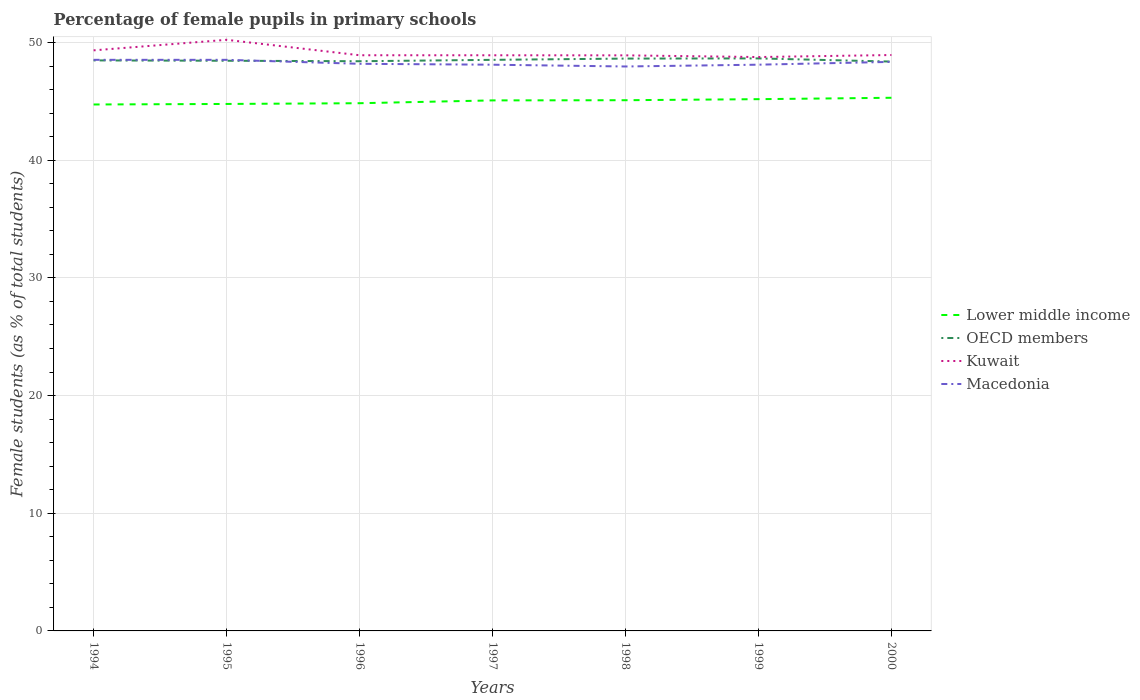Does the line corresponding to Macedonia intersect with the line corresponding to OECD members?
Provide a short and direct response. Yes. Across all years, what is the maximum percentage of female pupils in primary schools in OECD members?
Ensure brevity in your answer.  48.39. In which year was the percentage of female pupils in primary schools in Kuwait maximum?
Give a very brief answer. 1999. What is the total percentage of female pupils in primary schools in Macedonia in the graph?
Your answer should be compact. 0.34. What is the difference between the highest and the second highest percentage of female pupils in primary schools in OECD members?
Your response must be concise. 0.27. What is the difference between the highest and the lowest percentage of female pupils in primary schools in OECD members?
Provide a short and direct response. 3. Is the percentage of female pupils in primary schools in Kuwait strictly greater than the percentage of female pupils in primary schools in Lower middle income over the years?
Your answer should be very brief. No. How many lines are there?
Offer a terse response. 4. What is the difference between two consecutive major ticks on the Y-axis?
Provide a succinct answer. 10. Does the graph contain any zero values?
Provide a succinct answer. No. What is the title of the graph?
Keep it short and to the point. Percentage of female pupils in primary schools. What is the label or title of the Y-axis?
Offer a very short reply. Female students (as % of total students). What is the Female students (as % of total students) of Lower middle income in 1994?
Ensure brevity in your answer.  44.74. What is the Female students (as % of total students) in OECD members in 1994?
Offer a very short reply. 48.49. What is the Female students (as % of total students) of Kuwait in 1994?
Give a very brief answer. 49.34. What is the Female students (as % of total students) in Macedonia in 1994?
Keep it short and to the point. 48.54. What is the Female students (as % of total students) in Lower middle income in 1995?
Provide a succinct answer. 44.79. What is the Female students (as % of total students) in OECD members in 1995?
Offer a terse response. 48.46. What is the Female students (as % of total students) in Kuwait in 1995?
Your response must be concise. 50.24. What is the Female students (as % of total students) in Macedonia in 1995?
Make the answer very short. 48.54. What is the Female students (as % of total students) of Lower middle income in 1996?
Make the answer very short. 44.85. What is the Female students (as % of total students) of OECD members in 1996?
Your response must be concise. 48.42. What is the Female students (as % of total students) of Kuwait in 1996?
Offer a terse response. 48.93. What is the Female students (as % of total students) in Macedonia in 1996?
Your response must be concise. 48.2. What is the Female students (as % of total students) in Lower middle income in 1997?
Offer a terse response. 45.09. What is the Female students (as % of total students) of OECD members in 1997?
Provide a succinct answer. 48.54. What is the Female students (as % of total students) in Kuwait in 1997?
Your response must be concise. 48.92. What is the Female students (as % of total students) of Macedonia in 1997?
Your response must be concise. 48.12. What is the Female students (as % of total students) in Lower middle income in 1998?
Your response must be concise. 45.1. What is the Female students (as % of total students) in OECD members in 1998?
Your response must be concise. 48.64. What is the Female students (as % of total students) of Kuwait in 1998?
Keep it short and to the point. 48.92. What is the Female students (as % of total students) of Macedonia in 1998?
Provide a short and direct response. 47.97. What is the Female students (as % of total students) in Lower middle income in 1999?
Offer a very short reply. 45.19. What is the Female students (as % of total students) in OECD members in 1999?
Ensure brevity in your answer.  48.66. What is the Female students (as % of total students) of Kuwait in 1999?
Offer a terse response. 48.77. What is the Female students (as % of total students) in Macedonia in 1999?
Provide a short and direct response. 48.12. What is the Female students (as % of total students) in Lower middle income in 2000?
Keep it short and to the point. 45.31. What is the Female students (as % of total students) of OECD members in 2000?
Provide a succinct answer. 48.39. What is the Female students (as % of total students) of Kuwait in 2000?
Your response must be concise. 48.94. What is the Female students (as % of total students) of Macedonia in 2000?
Offer a very short reply. 48.36. Across all years, what is the maximum Female students (as % of total students) of Lower middle income?
Keep it short and to the point. 45.31. Across all years, what is the maximum Female students (as % of total students) of OECD members?
Ensure brevity in your answer.  48.66. Across all years, what is the maximum Female students (as % of total students) of Kuwait?
Your answer should be very brief. 50.24. Across all years, what is the maximum Female students (as % of total students) in Macedonia?
Offer a very short reply. 48.54. Across all years, what is the minimum Female students (as % of total students) in Lower middle income?
Ensure brevity in your answer.  44.74. Across all years, what is the minimum Female students (as % of total students) of OECD members?
Provide a short and direct response. 48.39. Across all years, what is the minimum Female students (as % of total students) in Kuwait?
Your answer should be very brief. 48.77. Across all years, what is the minimum Female students (as % of total students) in Macedonia?
Keep it short and to the point. 47.97. What is the total Female students (as % of total students) of Lower middle income in the graph?
Offer a terse response. 315.07. What is the total Female students (as % of total students) in OECD members in the graph?
Your answer should be compact. 339.58. What is the total Female students (as % of total students) in Kuwait in the graph?
Offer a terse response. 344.06. What is the total Female students (as % of total students) in Macedonia in the graph?
Provide a succinct answer. 337.85. What is the difference between the Female students (as % of total students) of Lower middle income in 1994 and that in 1995?
Give a very brief answer. -0.05. What is the difference between the Female students (as % of total students) in OECD members in 1994 and that in 1995?
Offer a very short reply. 0.03. What is the difference between the Female students (as % of total students) of Kuwait in 1994 and that in 1995?
Ensure brevity in your answer.  -0.9. What is the difference between the Female students (as % of total students) of Macedonia in 1994 and that in 1995?
Keep it short and to the point. 0. What is the difference between the Female students (as % of total students) in Lower middle income in 1994 and that in 1996?
Offer a terse response. -0.11. What is the difference between the Female students (as % of total students) in OECD members in 1994 and that in 1996?
Ensure brevity in your answer.  0.07. What is the difference between the Female students (as % of total students) in Kuwait in 1994 and that in 1996?
Keep it short and to the point. 0.42. What is the difference between the Female students (as % of total students) in Macedonia in 1994 and that in 1996?
Provide a succinct answer. 0.34. What is the difference between the Female students (as % of total students) of Lower middle income in 1994 and that in 1997?
Your answer should be compact. -0.35. What is the difference between the Female students (as % of total students) in OECD members in 1994 and that in 1997?
Provide a short and direct response. -0.05. What is the difference between the Female students (as % of total students) in Kuwait in 1994 and that in 1997?
Make the answer very short. 0.42. What is the difference between the Female students (as % of total students) in Macedonia in 1994 and that in 1997?
Your response must be concise. 0.42. What is the difference between the Female students (as % of total students) in Lower middle income in 1994 and that in 1998?
Your answer should be compact. -0.36. What is the difference between the Female students (as % of total students) in OECD members in 1994 and that in 1998?
Your answer should be very brief. -0.16. What is the difference between the Female students (as % of total students) of Kuwait in 1994 and that in 1998?
Offer a terse response. 0.43. What is the difference between the Female students (as % of total students) in Macedonia in 1994 and that in 1998?
Offer a terse response. 0.57. What is the difference between the Female students (as % of total students) of Lower middle income in 1994 and that in 1999?
Ensure brevity in your answer.  -0.45. What is the difference between the Female students (as % of total students) in OECD members in 1994 and that in 1999?
Provide a short and direct response. -0.17. What is the difference between the Female students (as % of total students) of Kuwait in 1994 and that in 1999?
Offer a terse response. 0.57. What is the difference between the Female students (as % of total students) in Macedonia in 1994 and that in 1999?
Your response must be concise. 0.41. What is the difference between the Female students (as % of total students) of Lower middle income in 1994 and that in 2000?
Offer a terse response. -0.57. What is the difference between the Female students (as % of total students) of OECD members in 1994 and that in 2000?
Give a very brief answer. 0.1. What is the difference between the Female students (as % of total students) in Kuwait in 1994 and that in 2000?
Keep it short and to the point. 0.4. What is the difference between the Female students (as % of total students) in Macedonia in 1994 and that in 2000?
Offer a very short reply. 0.17. What is the difference between the Female students (as % of total students) in Lower middle income in 1995 and that in 1996?
Keep it short and to the point. -0.06. What is the difference between the Female students (as % of total students) in OECD members in 1995 and that in 1996?
Provide a short and direct response. 0.04. What is the difference between the Female students (as % of total students) in Kuwait in 1995 and that in 1996?
Your answer should be very brief. 1.31. What is the difference between the Female students (as % of total students) in Macedonia in 1995 and that in 1996?
Ensure brevity in your answer.  0.34. What is the difference between the Female students (as % of total students) of Lower middle income in 1995 and that in 1997?
Ensure brevity in your answer.  -0.3. What is the difference between the Female students (as % of total students) of OECD members in 1995 and that in 1997?
Make the answer very short. -0.08. What is the difference between the Female students (as % of total students) in Kuwait in 1995 and that in 1997?
Your response must be concise. 1.31. What is the difference between the Female students (as % of total students) in Macedonia in 1995 and that in 1997?
Your answer should be very brief. 0.42. What is the difference between the Female students (as % of total students) of Lower middle income in 1995 and that in 1998?
Keep it short and to the point. -0.32. What is the difference between the Female students (as % of total students) of OECD members in 1995 and that in 1998?
Provide a short and direct response. -0.19. What is the difference between the Female students (as % of total students) of Kuwait in 1995 and that in 1998?
Give a very brief answer. 1.32. What is the difference between the Female students (as % of total students) in Macedonia in 1995 and that in 1998?
Your answer should be very brief. 0.57. What is the difference between the Female students (as % of total students) of Lower middle income in 1995 and that in 1999?
Keep it short and to the point. -0.41. What is the difference between the Female students (as % of total students) of OECD members in 1995 and that in 1999?
Make the answer very short. -0.2. What is the difference between the Female students (as % of total students) of Kuwait in 1995 and that in 1999?
Make the answer very short. 1.47. What is the difference between the Female students (as % of total students) in Macedonia in 1995 and that in 1999?
Offer a very short reply. 0.41. What is the difference between the Female students (as % of total students) of Lower middle income in 1995 and that in 2000?
Your answer should be compact. -0.53. What is the difference between the Female students (as % of total students) in OECD members in 1995 and that in 2000?
Your response must be concise. 0.07. What is the difference between the Female students (as % of total students) of Kuwait in 1995 and that in 2000?
Give a very brief answer. 1.29. What is the difference between the Female students (as % of total students) in Macedonia in 1995 and that in 2000?
Make the answer very short. 0.17. What is the difference between the Female students (as % of total students) of Lower middle income in 1996 and that in 1997?
Give a very brief answer. -0.24. What is the difference between the Female students (as % of total students) of OECD members in 1996 and that in 1997?
Make the answer very short. -0.12. What is the difference between the Female students (as % of total students) in Kuwait in 1996 and that in 1997?
Your answer should be compact. 0. What is the difference between the Female students (as % of total students) of Macedonia in 1996 and that in 1997?
Make the answer very short. 0.08. What is the difference between the Female students (as % of total students) in Lower middle income in 1996 and that in 1998?
Make the answer very short. -0.26. What is the difference between the Female students (as % of total students) in OECD members in 1996 and that in 1998?
Your answer should be very brief. -0.23. What is the difference between the Female students (as % of total students) of Kuwait in 1996 and that in 1998?
Your response must be concise. 0.01. What is the difference between the Female students (as % of total students) in Macedonia in 1996 and that in 1998?
Your answer should be compact. 0.23. What is the difference between the Female students (as % of total students) in Lower middle income in 1996 and that in 1999?
Your response must be concise. -0.34. What is the difference between the Female students (as % of total students) of OECD members in 1996 and that in 1999?
Your answer should be very brief. -0.24. What is the difference between the Female students (as % of total students) in Kuwait in 1996 and that in 1999?
Give a very brief answer. 0.15. What is the difference between the Female students (as % of total students) in Macedonia in 1996 and that in 1999?
Ensure brevity in your answer.  0.07. What is the difference between the Female students (as % of total students) of Lower middle income in 1996 and that in 2000?
Provide a short and direct response. -0.46. What is the difference between the Female students (as % of total students) in OECD members in 1996 and that in 2000?
Your answer should be very brief. 0.03. What is the difference between the Female students (as % of total students) in Kuwait in 1996 and that in 2000?
Your answer should be very brief. -0.02. What is the difference between the Female students (as % of total students) of Macedonia in 1996 and that in 2000?
Provide a succinct answer. -0.16. What is the difference between the Female students (as % of total students) of Lower middle income in 1997 and that in 1998?
Make the answer very short. -0.02. What is the difference between the Female students (as % of total students) of OECD members in 1997 and that in 1998?
Your response must be concise. -0.11. What is the difference between the Female students (as % of total students) of Kuwait in 1997 and that in 1998?
Provide a short and direct response. 0.01. What is the difference between the Female students (as % of total students) of Macedonia in 1997 and that in 1998?
Offer a very short reply. 0.15. What is the difference between the Female students (as % of total students) in Lower middle income in 1997 and that in 1999?
Offer a terse response. -0.1. What is the difference between the Female students (as % of total students) in OECD members in 1997 and that in 1999?
Give a very brief answer. -0.12. What is the difference between the Female students (as % of total students) of Kuwait in 1997 and that in 1999?
Your answer should be compact. 0.15. What is the difference between the Female students (as % of total students) in Macedonia in 1997 and that in 1999?
Keep it short and to the point. -0. What is the difference between the Female students (as % of total students) of Lower middle income in 1997 and that in 2000?
Provide a short and direct response. -0.22. What is the difference between the Female students (as % of total students) in OECD members in 1997 and that in 2000?
Provide a short and direct response. 0.15. What is the difference between the Female students (as % of total students) of Kuwait in 1997 and that in 2000?
Keep it short and to the point. -0.02. What is the difference between the Female students (as % of total students) of Macedonia in 1997 and that in 2000?
Your answer should be compact. -0.24. What is the difference between the Female students (as % of total students) of Lower middle income in 1998 and that in 1999?
Provide a short and direct response. -0.09. What is the difference between the Female students (as % of total students) of OECD members in 1998 and that in 1999?
Your answer should be compact. -0.01. What is the difference between the Female students (as % of total students) of Kuwait in 1998 and that in 1999?
Your response must be concise. 0.14. What is the difference between the Female students (as % of total students) of Macedonia in 1998 and that in 1999?
Offer a very short reply. -0.15. What is the difference between the Female students (as % of total students) of Lower middle income in 1998 and that in 2000?
Offer a very short reply. -0.21. What is the difference between the Female students (as % of total students) of OECD members in 1998 and that in 2000?
Ensure brevity in your answer.  0.26. What is the difference between the Female students (as % of total students) in Kuwait in 1998 and that in 2000?
Make the answer very short. -0.03. What is the difference between the Female students (as % of total students) in Macedonia in 1998 and that in 2000?
Make the answer very short. -0.39. What is the difference between the Female students (as % of total students) in Lower middle income in 1999 and that in 2000?
Keep it short and to the point. -0.12. What is the difference between the Female students (as % of total students) of OECD members in 1999 and that in 2000?
Ensure brevity in your answer.  0.27. What is the difference between the Female students (as % of total students) of Kuwait in 1999 and that in 2000?
Your answer should be compact. -0.17. What is the difference between the Female students (as % of total students) in Macedonia in 1999 and that in 2000?
Provide a succinct answer. -0.24. What is the difference between the Female students (as % of total students) of Lower middle income in 1994 and the Female students (as % of total students) of OECD members in 1995?
Provide a succinct answer. -3.72. What is the difference between the Female students (as % of total students) in Lower middle income in 1994 and the Female students (as % of total students) in Kuwait in 1995?
Your answer should be compact. -5.5. What is the difference between the Female students (as % of total students) in Lower middle income in 1994 and the Female students (as % of total students) in Macedonia in 1995?
Provide a succinct answer. -3.8. What is the difference between the Female students (as % of total students) of OECD members in 1994 and the Female students (as % of total students) of Kuwait in 1995?
Give a very brief answer. -1.75. What is the difference between the Female students (as % of total students) of Kuwait in 1994 and the Female students (as % of total students) of Macedonia in 1995?
Ensure brevity in your answer.  0.81. What is the difference between the Female students (as % of total students) in Lower middle income in 1994 and the Female students (as % of total students) in OECD members in 1996?
Offer a very short reply. -3.68. What is the difference between the Female students (as % of total students) of Lower middle income in 1994 and the Female students (as % of total students) of Kuwait in 1996?
Your answer should be compact. -4.18. What is the difference between the Female students (as % of total students) of Lower middle income in 1994 and the Female students (as % of total students) of Macedonia in 1996?
Make the answer very short. -3.46. What is the difference between the Female students (as % of total students) of OECD members in 1994 and the Female students (as % of total students) of Kuwait in 1996?
Your answer should be very brief. -0.44. What is the difference between the Female students (as % of total students) of OECD members in 1994 and the Female students (as % of total students) of Macedonia in 1996?
Make the answer very short. 0.29. What is the difference between the Female students (as % of total students) in Kuwait in 1994 and the Female students (as % of total students) in Macedonia in 1996?
Your response must be concise. 1.14. What is the difference between the Female students (as % of total students) in Lower middle income in 1994 and the Female students (as % of total students) in OECD members in 1997?
Make the answer very short. -3.79. What is the difference between the Female students (as % of total students) in Lower middle income in 1994 and the Female students (as % of total students) in Kuwait in 1997?
Your response must be concise. -4.18. What is the difference between the Female students (as % of total students) in Lower middle income in 1994 and the Female students (as % of total students) in Macedonia in 1997?
Your answer should be very brief. -3.38. What is the difference between the Female students (as % of total students) in OECD members in 1994 and the Female students (as % of total students) in Kuwait in 1997?
Your response must be concise. -0.44. What is the difference between the Female students (as % of total students) in OECD members in 1994 and the Female students (as % of total students) in Macedonia in 1997?
Your answer should be very brief. 0.37. What is the difference between the Female students (as % of total students) of Kuwait in 1994 and the Female students (as % of total students) of Macedonia in 1997?
Your response must be concise. 1.22. What is the difference between the Female students (as % of total students) in Lower middle income in 1994 and the Female students (as % of total students) in OECD members in 1998?
Keep it short and to the point. -3.9. What is the difference between the Female students (as % of total students) of Lower middle income in 1994 and the Female students (as % of total students) of Kuwait in 1998?
Provide a short and direct response. -4.18. What is the difference between the Female students (as % of total students) of Lower middle income in 1994 and the Female students (as % of total students) of Macedonia in 1998?
Provide a short and direct response. -3.23. What is the difference between the Female students (as % of total students) of OECD members in 1994 and the Female students (as % of total students) of Kuwait in 1998?
Ensure brevity in your answer.  -0.43. What is the difference between the Female students (as % of total students) of OECD members in 1994 and the Female students (as % of total students) of Macedonia in 1998?
Your response must be concise. 0.52. What is the difference between the Female students (as % of total students) of Kuwait in 1994 and the Female students (as % of total students) of Macedonia in 1998?
Offer a very short reply. 1.37. What is the difference between the Female students (as % of total students) of Lower middle income in 1994 and the Female students (as % of total students) of OECD members in 1999?
Offer a very short reply. -3.92. What is the difference between the Female students (as % of total students) in Lower middle income in 1994 and the Female students (as % of total students) in Kuwait in 1999?
Your answer should be compact. -4.03. What is the difference between the Female students (as % of total students) of Lower middle income in 1994 and the Female students (as % of total students) of Macedonia in 1999?
Your answer should be very brief. -3.38. What is the difference between the Female students (as % of total students) of OECD members in 1994 and the Female students (as % of total students) of Kuwait in 1999?
Your answer should be very brief. -0.29. What is the difference between the Female students (as % of total students) of OECD members in 1994 and the Female students (as % of total students) of Macedonia in 1999?
Offer a very short reply. 0.36. What is the difference between the Female students (as % of total students) of Kuwait in 1994 and the Female students (as % of total students) of Macedonia in 1999?
Give a very brief answer. 1.22. What is the difference between the Female students (as % of total students) of Lower middle income in 1994 and the Female students (as % of total students) of OECD members in 2000?
Ensure brevity in your answer.  -3.65. What is the difference between the Female students (as % of total students) of Lower middle income in 1994 and the Female students (as % of total students) of Kuwait in 2000?
Your answer should be compact. -4.2. What is the difference between the Female students (as % of total students) of Lower middle income in 1994 and the Female students (as % of total students) of Macedonia in 2000?
Give a very brief answer. -3.62. What is the difference between the Female students (as % of total students) in OECD members in 1994 and the Female students (as % of total students) in Kuwait in 2000?
Give a very brief answer. -0.46. What is the difference between the Female students (as % of total students) in OECD members in 1994 and the Female students (as % of total students) in Macedonia in 2000?
Offer a terse response. 0.12. What is the difference between the Female students (as % of total students) in Kuwait in 1994 and the Female students (as % of total students) in Macedonia in 2000?
Provide a succinct answer. 0.98. What is the difference between the Female students (as % of total students) of Lower middle income in 1995 and the Female students (as % of total students) of OECD members in 1996?
Give a very brief answer. -3.63. What is the difference between the Female students (as % of total students) of Lower middle income in 1995 and the Female students (as % of total students) of Kuwait in 1996?
Offer a terse response. -4.14. What is the difference between the Female students (as % of total students) of Lower middle income in 1995 and the Female students (as % of total students) of Macedonia in 1996?
Your response must be concise. -3.41. What is the difference between the Female students (as % of total students) in OECD members in 1995 and the Female students (as % of total students) in Kuwait in 1996?
Provide a succinct answer. -0.47. What is the difference between the Female students (as % of total students) of OECD members in 1995 and the Female students (as % of total students) of Macedonia in 1996?
Offer a terse response. 0.26. What is the difference between the Female students (as % of total students) in Kuwait in 1995 and the Female students (as % of total students) in Macedonia in 1996?
Provide a succinct answer. 2.04. What is the difference between the Female students (as % of total students) in Lower middle income in 1995 and the Female students (as % of total students) in OECD members in 1997?
Your answer should be very brief. -3.75. What is the difference between the Female students (as % of total students) of Lower middle income in 1995 and the Female students (as % of total students) of Kuwait in 1997?
Make the answer very short. -4.14. What is the difference between the Female students (as % of total students) in Lower middle income in 1995 and the Female students (as % of total students) in Macedonia in 1997?
Your answer should be compact. -3.34. What is the difference between the Female students (as % of total students) in OECD members in 1995 and the Female students (as % of total students) in Kuwait in 1997?
Give a very brief answer. -0.47. What is the difference between the Female students (as % of total students) in OECD members in 1995 and the Female students (as % of total students) in Macedonia in 1997?
Your response must be concise. 0.34. What is the difference between the Female students (as % of total students) of Kuwait in 1995 and the Female students (as % of total students) of Macedonia in 1997?
Ensure brevity in your answer.  2.12. What is the difference between the Female students (as % of total students) of Lower middle income in 1995 and the Female students (as % of total students) of OECD members in 1998?
Provide a short and direct response. -3.86. What is the difference between the Female students (as % of total students) in Lower middle income in 1995 and the Female students (as % of total students) in Kuwait in 1998?
Your answer should be compact. -4.13. What is the difference between the Female students (as % of total students) in Lower middle income in 1995 and the Female students (as % of total students) in Macedonia in 1998?
Offer a terse response. -3.18. What is the difference between the Female students (as % of total students) in OECD members in 1995 and the Female students (as % of total students) in Kuwait in 1998?
Keep it short and to the point. -0.46. What is the difference between the Female students (as % of total students) in OECD members in 1995 and the Female students (as % of total students) in Macedonia in 1998?
Provide a short and direct response. 0.49. What is the difference between the Female students (as % of total students) in Kuwait in 1995 and the Female students (as % of total students) in Macedonia in 1998?
Provide a short and direct response. 2.27. What is the difference between the Female students (as % of total students) of Lower middle income in 1995 and the Female students (as % of total students) of OECD members in 1999?
Keep it short and to the point. -3.87. What is the difference between the Female students (as % of total students) of Lower middle income in 1995 and the Female students (as % of total students) of Kuwait in 1999?
Offer a terse response. -3.99. What is the difference between the Female students (as % of total students) of Lower middle income in 1995 and the Female students (as % of total students) of Macedonia in 1999?
Provide a succinct answer. -3.34. What is the difference between the Female students (as % of total students) of OECD members in 1995 and the Female students (as % of total students) of Kuwait in 1999?
Ensure brevity in your answer.  -0.31. What is the difference between the Female students (as % of total students) of OECD members in 1995 and the Female students (as % of total students) of Macedonia in 1999?
Make the answer very short. 0.33. What is the difference between the Female students (as % of total students) in Kuwait in 1995 and the Female students (as % of total students) in Macedonia in 1999?
Your answer should be very brief. 2.11. What is the difference between the Female students (as % of total students) in Lower middle income in 1995 and the Female students (as % of total students) in OECD members in 2000?
Offer a terse response. -3.6. What is the difference between the Female students (as % of total students) in Lower middle income in 1995 and the Female students (as % of total students) in Kuwait in 2000?
Make the answer very short. -4.16. What is the difference between the Female students (as % of total students) in Lower middle income in 1995 and the Female students (as % of total students) in Macedonia in 2000?
Your answer should be compact. -3.58. What is the difference between the Female students (as % of total students) in OECD members in 1995 and the Female students (as % of total students) in Kuwait in 2000?
Your response must be concise. -0.49. What is the difference between the Female students (as % of total students) of OECD members in 1995 and the Female students (as % of total students) of Macedonia in 2000?
Provide a short and direct response. 0.1. What is the difference between the Female students (as % of total students) in Kuwait in 1995 and the Female students (as % of total students) in Macedonia in 2000?
Give a very brief answer. 1.88. What is the difference between the Female students (as % of total students) in Lower middle income in 1996 and the Female students (as % of total students) in OECD members in 1997?
Make the answer very short. -3.69. What is the difference between the Female students (as % of total students) of Lower middle income in 1996 and the Female students (as % of total students) of Kuwait in 1997?
Make the answer very short. -4.07. What is the difference between the Female students (as % of total students) in Lower middle income in 1996 and the Female students (as % of total students) in Macedonia in 1997?
Your answer should be compact. -3.27. What is the difference between the Female students (as % of total students) in OECD members in 1996 and the Female students (as % of total students) in Kuwait in 1997?
Offer a very short reply. -0.51. What is the difference between the Female students (as % of total students) in OECD members in 1996 and the Female students (as % of total students) in Macedonia in 1997?
Keep it short and to the point. 0.3. What is the difference between the Female students (as % of total students) of Kuwait in 1996 and the Female students (as % of total students) of Macedonia in 1997?
Your response must be concise. 0.8. What is the difference between the Female students (as % of total students) of Lower middle income in 1996 and the Female students (as % of total students) of OECD members in 1998?
Provide a succinct answer. -3.79. What is the difference between the Female students (as % of total students) in Lower middle income in 1996 and the Female students (as % of total students) in Kuwait in 1998?
Provide a short and direct response. -4.07. What is the difference between the Female students (as % of total students) of Lower middle income in 1996 and the Female students (as % of total students) of Macedonia in 1998?
Keep it short and to the point. -3.12. What is the difference between the Female students (as % of total students) of OECD members in 1996 and the Female students (as % of total students) of Kuwait in 1998?
Ensure brevity in your answer.  -0.5. What is the difference between the Female students (as % of total students) of OECD members in 1996 and the Female students (as % of total students) of Macedonia in 1998?
Your answer should be very brief. 0.45. What is the difference between the Female students (as % of total students) in Kuwait in 1996 and the Female students (as % of total students) in Macedonia in 1998?
Ensure brevity in your answer.  0.96. What is the difference between the Female students (as % of total students) in Lower middle income in 1996 and the Female students (as % of total students) in OECD members in 1999?
Give a very brief answer. -3.81. What is the difference between the Female students (as % of total students) in Lower middle income in 1996 and the Female students (as % of total students) in Kuwait in 1999?
Give a very brief answer. -3.92. What is the difference between the Female students (as % of total students) in Lower middle income in 1996 and the Female students (as % of total students) in Macedonia in 1999?
Your answer should be very brief. -3.27. What is the difference between the Female students (as % of total students) of OECD members in 1996 and the Female students (as % of total students) of Kuwait in 1999?
Your answer should be compact. -0.36. What is the difference between the Female students (as % of total students) in OECD members in 1996 and the Female students (as % of total students) in Macedonia in 1999?
Offer a terse response. 0.29. What is the difference between the Female students (as % of total students) of Kuwait in 1996 and the Female students (as % of total students) of Macedonia in 1999?
Your answer should be very brief. 0.8. What is the difference between the Female students (as % of total students) of Lower middle income in 1996 and the Female students (as % of total students) of OECD members in 2000?
Provide a short and direct response. -3.54. What is the difference between the Female students (as % of total students) in Lower middle income in 1996 and the Female students (as % of total students) in Kuwait in 2000?
Ensure brevity in your answer.  -4.1. What is the difference between the Female students (as % of total students) in Lower middle income in 1996 and the Female students (as % of total students) in Macedonia in 2000?
Keep it short and to the point. -3.51. What is the difference between the Female students (as % of total students) in OECD members in 1996 and the Female students (as % of total students) in Kuwait in 2000?
Offer a very short reply. -0.53. What is the difference between the Female students (as % of total students) of OECD members in 1996 and the Female students (as % of total students) of Macedonia in 2000?
Your answer should be very brief. 0.06. What is the difference between the Female students (as % of total students) of Kuwait in 1996 and the Female students (as % of total students) of Macedonia in 2000?
Ensure brevity in your answer.  0.56. What is the difference between the Female students (as % of total students) of Lower middle income in 1997 and the Female students (as % of total students) of OECD members in 1998?
Ensure brevity in your answer.  -3.55. What is the difference between the Female students (as % of total students) in Lower middle income in 1997 and the Female students (as % of total students) in Kuwait in 1998?
Your answer should be very brief. -3.83. What is the difference between the Female students (as % of total students) in Lower middle income in 1997 and the Female students (as % of total students) in Macedonia in 1998?
Your answer should be compact. -2.88. What is the difference between the Female students (as % of total students) of OECD members in 1997 and the Female students (as % of total students) of Kuwait in 1998?
Provide a succinct answer. -0.38. What is the difference between the Female students (as % of total students) of OECD members in 1997 and the Female students (as % of total students) of Macedonia in 1998?
Keep it short and to the point. 0.56. What is the difference between the Female students (as % of total students) of Lower middle income in 1997 and the Female students (as % of total students) of OECD members in 1999?
Offer a terse response. -3.57. What is the difference between the Female students (as % of total students) of Lower middle income in 1997 and the Female students (as % of total students) of Kuwait in 1999?
Ensure brevity in your answer.  -3.68. What is the difference between the Female students (as % of total students) in Lower middle income in 1997 and the Female students (as % of total students) in Macedonia in 1999?
Your response must be concise. -3.03. What is the difference between the Female students (as % of total students) of OECD members in 1997 and the Female students (as % of total students) of Kuwait in 1999?
Ensure brevity in your answer.  -0.24. What is the difference between the Female students (as % of total students) of OECD members in 1997 and the Female students (as % of total students) of Macedonia in 1999?
Offer a terse response. 0.41. What is the difference between the Female students (as % of total students) in Kuwait in 1997 and the Female students (as % of total students) in Macedonia in 1999?
Your response must be concise. 0.8. What is the difference between the Female students (as % of total students) in Lower middle income in 1997 and the Female students (as % of total students) in OECD members in 2000?
Provide a succinct answer. -3.3. What is the difference between the Female students (as % of total students) in Lower middle income in 1997 and the Female students (as % of total students) in Kuwait in 2000?
Ensure brevity in your answer.  -3.86. What is the difference between the Female students (as % of total students) of Lower middle income in 1997 and the Female students (as % of total students) of Macedonia in 2000?
Provide a succinct answer. -3.27. What is the difference between the Female students (as % of total students) of OECD members in 1997 and the Female students (as % of total students) of Kuwait in 2000?
Your answer should be very brief. -0.41. What is the difference between the Female students (as % of total students) in OECD members in 1997 and the Female students (as % of total students) in Macedonia in 2000?
Your answer should be very brief. 0.17. What is the difference between the Female students (as % of total students) of Kuwait in 1997 and the Female students (as % of total students) of Macedonia in 2000?
Keep it short and to the point. 0.56. What is the difference between the Female students (as % of total students) of Lower middle income in 1998 and the Female students (as % of total students) of OECD members in 1999?
Keep it short and to the point. -3.55. What is the difference between the Female students (as % of total students) of Lower middle income in 1998 and the Female students (as % of total students) of Kuwait in 1999?
Your answer should be very brief. -3.67. What is the difference between the Female students (as % of total students) in Lower middle income in 1998 and the Female students (as % of total students) in Macedonia in 1999?
Provide a succinct answer. -3.02. What is the difference between the Female students (as % of total students) in OECD members in 1998 and the Female students (as % of total students) in Kuwait in 1999?
Offer a terse response. -0.13. What is the difference between the Female students (as % of total students) in OECD members in 1998 and the Female students (as % of total students) in Macedonia in 1999?
Keep it short and to the point. 0.52. What is the difference between the Female students (as % of total students) in Kuwait in 1998 and the Female students (as % of total students) in Macedonia in 1999?
Provide a short and direct response. 0.79. What is the difference between the Female students (as % of total students) of Lower middle income in 1998 and the Female students (as % of total students) of OECD members in 2000?
Give a very brief answer. -3.28. What is the difference between the Female students (as % of total students) of Lower middle income in 1998 and the Female students (as % of total students) of Kuwait in 2000?
Provide a succinct answer. -3.84. What is the difference between the Female students (as % of total students) of Lower middle income in 1998 and the Female students (as % of total students) of Macedonia in 2000?
Your response must be concise. -3.26. What is the difference between the Female students (as % of total students) of OECD members in 1998 and the Female students (as % of total students) of Kuwait in 2000?
Provide a succinct answer. -0.3. What is the difference between the Female students (as % of total students) in OECD members in 1998 and the Female students (as % of total students) in Macedonia in 2000?
Your answer should be compact. 0.28. What is the difference between the Female students (as % of total students) of Kuwait in 1998 and the Female students (as % of total students) of Macedonia in 2000?
Keep it short and to the point. 0.55. What is the difference between the Female students (as % of total students) in Lower middle income in 1999 and the Female students (as % of total students) in OECD members in 2000?
Provide a succinct answer. -3.19. What is the difference between the Female students (as % of total students) of Lower middle income in 1999 and the Female students (as % of total students) of Kuwait in 2000?
Provide a succinct answer. -3.75. What is the difference between the Female students (as % of total students) in Lower middle income in 1999 and the Female students (as % of total students) in Macedonia in 2000?
Your answer should be very brief. -3.17. What is the difference between the Female students (as % of total students) in OECD members in 1999 and the Female students (as % of total students) in Kuwait in 2000?
Your answer should be compact. -0.29. What is the difference between the Female students (as % of total students) in OECD members in 1999 and the Female students (as % of total students) in Macedonia in 2000?
Make the answer very short. 0.3. What is the difference between the Female students (as % of total students) of Kuwait in 1999 and the Female students (as % of total students) of Macedonia in 2000?
Your answer should be very brief. 0.41. What is the average Female students (as % of total students) in Lower middle income per year?
Make the answer very short. 45.01. What is the average Female students (as % of total students) in OECD members per year?
Provide a short and direct response. 48.51. What is the average Female students (as % of total students) of Kuwait per year?
Provide a short and direct response. 49.15. What is the average Female students (as % of total students) of Macedonia per year?
Your answer should be very brief. 48.26. In the year 1994, what is the difference between the Female students (as % of total students) in Lower middle income and Female students (as % of total students) in OECD members?
Your response must be concise. -3.75. In the year 1994, what is the difference between the Female students (as % of total students) in Lower middle income and Female students (as % of total students) in Kuwait?
Offer a very short reply. -4.6. In the year 1994, what is the difference between the Female students (as % of total students) in Lower middle income and Female students (as % of total students) in Macedonia?
Offer a terse response. -3.8. In the year 1994, what is the difference between the Female students (as % of total students) of OECD members and Female students (as % of total students) of Kuwait?
Your answer should be compact. -0.86. In the year 1994, what is the difference between the Female students (as % of total students) in OECD members and Female students (as % of total students) in Macedonia?
Your answer should be very brief. -0.05. In the year 1994, what is the difference between the Female students (as % of total students) in Kuwait and Female students (as % of total students) in Macedonia?
Your answer should be compact. 0.81. In the year 1995, what is the difference between the Female students (as % of total students) in Lower middle income and Female students (as % of total students) in OECD members?
Provide a succinct answer. -3.67. In the year 1995, what is the difference between the Female students (as % of total students) in Lower middle income and Female students (as % of total students) in Kuwait?
Your answer should be very brief. -5.45. In the year 1995, what is the difference between the Female students (as % of total students) in Lower middle income and Female students (as % of total students) in Macedonia?
Provide a succinct answer. -3.75. In the year 1995, what is the difference between the Female students (as % of total students) of OECD members and Female students (as % of total students) of Kuwait?
Make the answer very short. -1.78. In the year 1995, what is the difference between the Female students (as % of total students) in OECD members and Female students (as % of total students) in Macedonia?
Ensure brevity in your answer.  -0.08. In the year 1995, what is the difference between the Female students (as % of total students) in Kuwait and Female students (as % of total students) in Macedonia?
Keep it short and to the point. 1.7. In the year 1996, what is the difference between the Female students (as % of total students) in Lower middle income and Female students (as % of total students) in OECD members?
Keep it short and to the point. -3.57. In the year 1996, what is the difference between the Female students (as % of total students) in Lower middle income and Female students (as % of total students) in Kuwait?
Provide a succinct answer. -4.08. In the year 1996, what is the difference between the Female students (as % of total students) in Lower middle income and Female students (as % of total students) in Macedonia?
Ensure brevity in your answer.  -3.35. In the year 1996, what is the difference between the Female students (as % of total students) in OECD members and Female students (as % of total students) in Kuwait?
Offer a very short reply. -0.51. In the year 1996, what is the difference between the Female students (as % of total students) of OECD members and Female students (as % of total students) of Macedonia?
Your answer should be very brief. 0.22. In the year 1996, what is the difference between the Female students (as % of total students) of Kuwait and Female students (as % of total students) of Macedonia?
Keep it short and to the point. 0.73. In the year 1997, what is the difference between the Female students (as % of total students) of Lower middle income and Female students (as % of total students) of OECD members?
Provide a short and direct response. -3.45. In the year 1997, what is the difference between the Female students (as % of total students) of Lower middle income and Female students (as % of total students) of Kuwait?
Provide a short and direct response. -3.83. In the year 1997, what is the difference between the Female students (as % of total students) in Lower middle income and Female students (as % of total students) in Macedonia?
Offer a very short reply. -3.03. In the year 1997, what is the difference between the Female students (as % of total students) of OECD members and Female students (as % of total students) of Kuwait?
Keep it short and to the point. -0.39. In the year 1997, what is the difference between the Female students (as % of total students) in OECD members and Female students (as % of total students) in Macedonia?
Your response must be concise. 0.41. In the year 1997, what is the difference between the Female students (as % of total students) of Kuwait and Female students (as % of total students) of Macedonia?
Offer a very short reply. 0.8. In the year 1998, what is the difference between the Female students (as % of total students) of Lower middle income and Female students (as % of total students) of OECD members?
Provide a short and direct response. -3.54. In the year 1998, what is the difference between the Female students (as % of total students) of Lower middle income and Female students (as % of total students) of Kuwait?
Your response must be concise. -3.81. In the year 1998, what is the difference between the Female students (as % of total students) of Lower middle income and Female students (as % of total students) of Macedonia?
Offer a terse response. -2.87. In the year 1998, what is the difference between the Female students (as % of total students) of OECD members and Female students (as % of total students) of Kuwait?
Provide a short and direct response. -0.27. In the year 1998, what is the difference between the Female students (as % of total students) of OECD members and Female students (as % of total students) of Macedonia?
Make the answer very short. 0.67. In the year 1998, what is the difference between the Female students (as % of total students) in Kuwait and Female students (as % of total students) in Macedonia?
Your response must be concise. 0.95. In the year 1999, what is the difference between the Female students (as % of total students) in Lower middle income and Female students (as % of total students) in OECD members?
Your answer should be compact. -3.46. In the year 1999, what is the difference between the Female students (as % of total students) in Lower middle income and Female students (as % of total students) in Kuwait?
Ensure brevity in your answer.  -3.58. In the year 1999, what is the difference between the Female students (as % of total students) of Lower middle income and Female students (as % of total students) of Macedonia?
Provide a short and direct response. -2.93. In the year 1999, what is the difference between the Female students (as % of total students) of OECD members and Female students (as % of total students) of Kuwait?
Make the answer very short. -0.12. In the year 1999, what is the difference between the Female students (as % of total students) in OECD members and Female students (as % of total students) in Macedonia?
Provide a succinct answer. 0.53. In the year 1999, what is the difference between the Female students (as % of total students) of Kuwait and Female students (as % of total students) of Macedonia?
Your answer should be very brief. 0.65. In the year 2000, what is the difference between the Female students (as % of total students) in Lower middle income and Female students (as % of total students) in OECD members?
Offer a very short reply. -3.08. In the year 2000, what is the difference between the Female students (as % of total students) of Lower middle income and Female students (as % of total students) of Kuwait?
Provide a succinct answer. -3.63. In the year 2000, what is the difference between the Female students (as % of total students) in Lower middle income and Female students (as % of total students) in Macedonia?
Make the answer very short. -3.05. In the year 2000, what is the difference between the Female students (as % of total students) in OECD members and Female students (as % of total students) in Kuwait?
Offer a very short reply. -0.56. In the year 2000, what is the difference between the Female students (as % of total students) of OECD members and Female students (as % of total students) of Macedonia?
Make the answer very short. 0.03. In the year 2000, what is the difference between the Female students (as % of total students) in Kuwait and Female students (as % of total students) in Macedonia?
Give a very brief answer. 0.58. What is the ratio of the Female students (as % of total students) of Kuwait in 1994 to that in 1995?
Your response must be concise. 0.98. What is the ratio of the Female students (as % of total students) of Lower middle income in 1994 to that in 1996?
Keep it short and to the point. 1. What is the ratio of the Female students (as % of total students) in OECD members in 1994 to that in 1996?
Keep it short and to the point. 1. What is the ratio of the Female students (as % of total students) in Kuwait in 1994 to that in 1996?
Your answer should be very brief. 1.01. What is the ratio of the Female students (as % of total students) of Macedonia in 1994 to that in 1996?
Your response must be concise. 1.01. What is the ratio of the Female students (as % of total students) in Lower middle income in 1994 to that in 1997?
Your answer should be compact. 0.99. What is the ratio of the Female students (as % of total students) in OECD members in 1994 to that in 1997?
Give a very brief answer. 1. What is the ratio of the Female students (as % of total students) of Kuwait in 1994 to that in 1997?
Provide a short and direct response. 1.01. What is the ratio of the Female students (as % of total students) in Macedonia in 1994 to that in 1997?
Offer a terse response. 1.01. What is the ratio of the Female students (as % of total students) in Lower middle income in 1994 to that in 1998?
Make the answer very short. 0.99. What is the ratio of the Female students (as % of total students) in OECD members in 1994 to that in 1998?
Make the answer very short. 1. What is the ratio of the Female students (as % of total students) in Kuwait in 1994 to that in 1998?
Offer a very short reply. 1.01. What is the ratio of the Female students (as % of total students) of Macedonia in 1994 to that in 1998?
Provide a short and direct response. 1.01. What is the ratio of the Female students (as % of total students) of Lower middle income in 1994 to that in 1999?
Provide a succinct answer. 0.99. What is the ratio of the Female students (as % of total students) of OECD members in 1994 to that in 1999?
Offer a terse response. 1. What is the ratio of the Female students (as % of total students) in Kuwait in 1994 to that in 1999?
Your answer should be compact. 1.01. What is the ratio of the Female students (as % of total students) of Macedonia in 1994 to that in 1999?
Your response must be concise. 1.01. What is the ratio of the Female students (as % of total students) in Lower middle income in 1994 to that in 2000?
Your answer should be very brief. 0.99. What is the ratio of the Female students (as % of total students) of OECD members in 1994 to that in 2000?
Give a very brief answer. 1. What is the ratio of the Female students (as % of total students) of Macedonia in 1994 to that in 2000?
Keep it short and to the point. 1. What is the ratio of the Female students (as % of total students) in Lower middle income in 1995 to that in 1996?
Make the answer very short. 1. What is the ratio of the Female students (as % of total students) of OECD members in 1995 to that in 1996?
Keep it short and to the point. 1. What is the ratio of the Female students (as % of total students) in Kuwait in 1995 to that in 1996?
Offer a terse response. 1.03. What is the ratio of the Female students (as % of total students) of Macedonia in 1995 to that in 1996?
Offer a very short reply. 1.01. What is the ratio of the Female students (as % of total students) in Lower middle income in 1995 to that in 1997?
Keep it short and to the point. 0.99. What is the ratio of the Female students (as % of total students) of Kuwait in 1995 to that in 1997?
Keep it short and to the point. 1.03. What is the ratio of the Female students (as % of total students) in Macedonia in 1995 to that in 1997?
Offer a very short reply. 1.01. What is the ratio of the Female students (as % of total students) of Lower middle income in 1995 to that in 1998?
Offer a terse response. 0.99. What is the ratio of the Female students (as % of total students) in Macedonia in 1995 to that in 1998?
Offer a very short reply. 1.01. What is the ratio of the Female students (as % of total students) of Macedonia in 1995 to that in 1999?
Your answer should be very brief. 1.01. What is the ratio of the Female students (as % of total students) of Lower middle income in 1995 to that in 2000?
Offer a terse response. 0.99. What is the ratio of the Female students (as % of total students) of OECD members in 1995 to that in 2000?
Provide a short and direct response. 1. What is the ratio of the Female students (as % of total students) of Kuwait in 1995 to that in 2000?
Make the answer very short. 1.03. What is the ratio of the Female students (as % of total students) in Macedonia in 1995 to that in 2000?
Your answer should be very brief. 1. What is the ratio of the Female students (as % of total students) of Kuwait in 1996 to that in 1997?
Your answer should be compact. 1. What is the ratio of the Female students (as % of total students) of Lower middle income in 1996 to that in 1998?
Make the answer very short. 0.99. What is the ratio of the Female students (as % of total students) of OECD members in 1996 to that in 1998?
Your answer should be very brief. 1. What is the ratio of the Female students (as % of total students) of Kuwait in 1996 to that in 1998?
Your answer should be very brief. 1. What is the ratio of the Female students (as % of total students) of Macedonia in 1996 to that in 1998?
Give a very brief answer. 1. What is the ratio of the Female students (as % of total students) of Kuwait in 1996 to that in 1999?
Your answer should be very brief. 1. What is the ratio of the Female students (as % of total students) in Macedonia in 1996 to that in 1999?
Your answer should be very brief. 1. What is the ratio of the Female students (as % of total students) in Lower middle income in 1996 to that in 2000?
Keep it short and to the point. 0.99. What is the ratio of the Female students (as % of total students) in OECD members in 1996 to that in 2000?
Your answer should be compact. 1. What is the ratio of the Female students (as % of total students) of Kuwait in 1996 to that in 2000?
Offer a very short reply. 1. What is the ratio of the Female students (as % of total students) of Macedonia in 1996 to that in 2000?
Keep it short and to the point. 1. What is the ratio of the Female students (as % of total students) of Lower middle income in 1997 to that in 1998?
Keep it short and to the point. 1. What is the ratio of the Female students (as % of total students) of Kuwait in 1997 to that in 1999?
Provide a short and direct response. 1. What is the ratio of the Female students (as % of total students) of Macedonia in 1997 to that in 1999?
Make the answer very short. 1. What is the ratio of the Female students (as % of total students) of OECD members in 1998 to that in 1999?
Your answer should be very brief. 1. What is the ratio of the Female students (as % of total students) of Kuwait in 1998 to that in 1999?
Provide a short and direct response. 1. What is the ratio of the Female students (as % of total students) of Macedonia in 1998 to that in 1999?
Your answer should be very brief. 1. What is the ratio of the Female students (as % of total students) of Lower middle income in 1998 to that in 2000?
Your answer should be very brief. 1. What is the ratio of the Female students (as % of total students) in OECD members in 1998 to that in 2000?
Offer a terse response. 1.01. What is the ratio of the Female students (as % of total students) in Lower middle income in 1999 to that in 2000?
Provide a short and direct response. 1. What is the ratio of the Female students (as % of total students) of OECD members in 1999 to that in 2000?
Make the answer very short. 1.01. What is the ratio of the Female students (as % of total students) of Macedonia in 1999 to that in 2000?
Ensure brevity in your answer.  1. What is the difference between the highest and the second highest Female students (as % of total students) in Lower middle income?
Make the answer very short. 0.12. What is the difference between the highest and the second highest Female students (as % of total students) of OECD members?
Provide a succinct answer. 0.01. What is the difference between the highest and the second highest Female students (as % of total students) of Kuwait?
Make the answer very short. 0.9. What is the difference between the highest and the second highest Female students (as % of total students) of Macedonia?
Make the answer very short. 0. What is the difference between the highest and the lowest Female students (as % of total students) in Lower middle income?
Offer a very short reply. 0.57. What is the difference between the highest and the lowest Female students (as % of total students) in OECD members?
Offer a very short reply. 0.27. What is the difference between the highest and the lowest Female students (as % of total students) in Kuwait?
Give a very brief answer. 1.47. What is the difference between the highest and the lowest Female students (as % of total students) in Macedonia?
Your response must be concise. 0.57. 